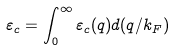Convert formula to latex. <formula><loc_0><loc_0><loc_500><loc_500>\varepsilon _ { c } = \int _ { 0 } ^ { \infty } \varepsilon _ { c } ( q ) d ( q / k _ { F } )</formula> 